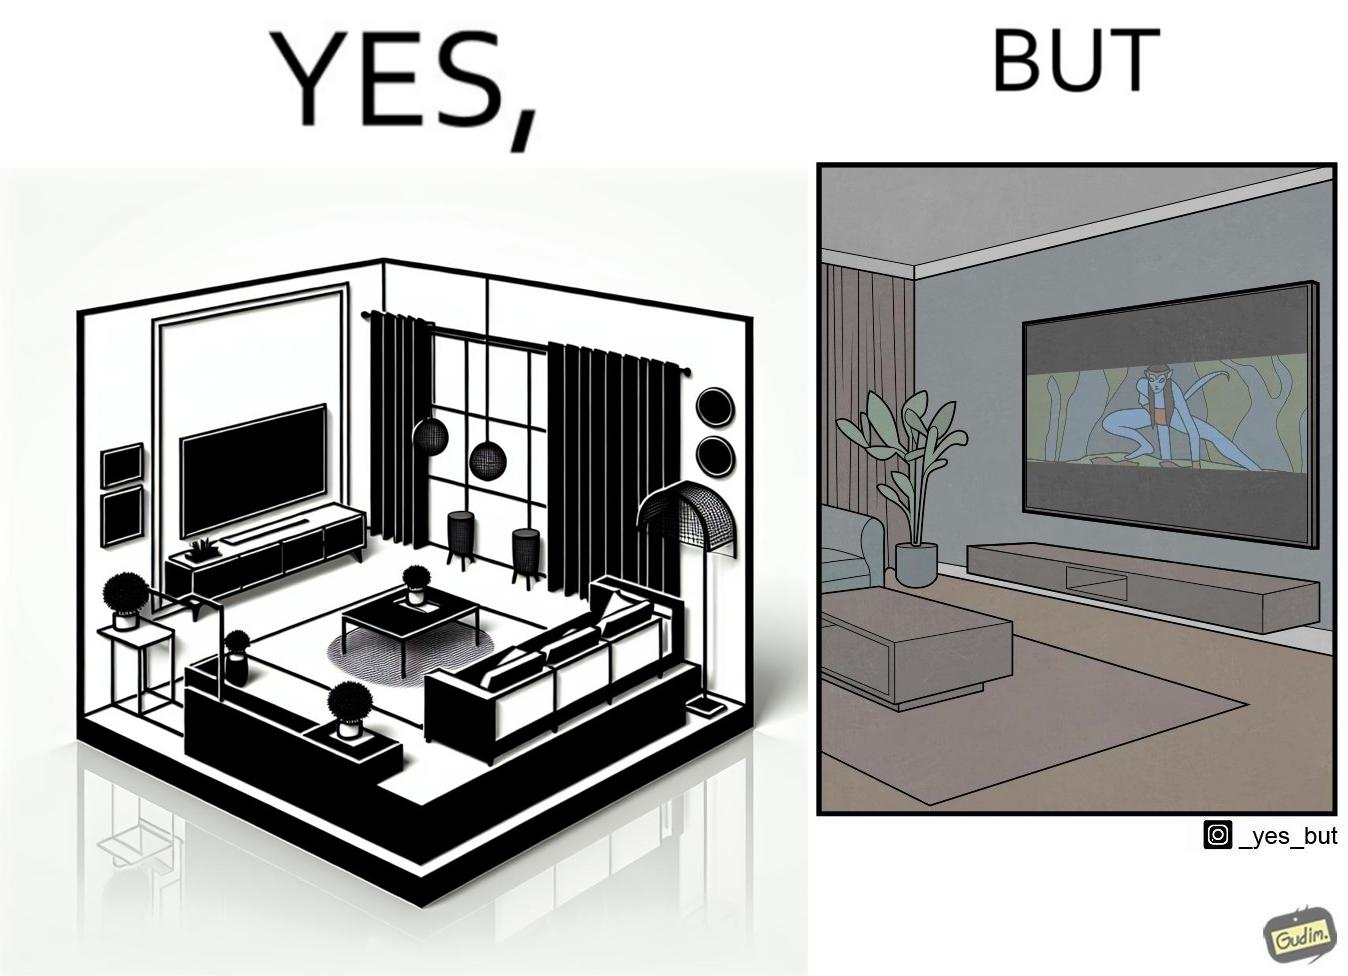What makes this image funny or satirical? The image is funny because while the room has a big TV with a big screen, the movie being played on it does not use the entire screen. 